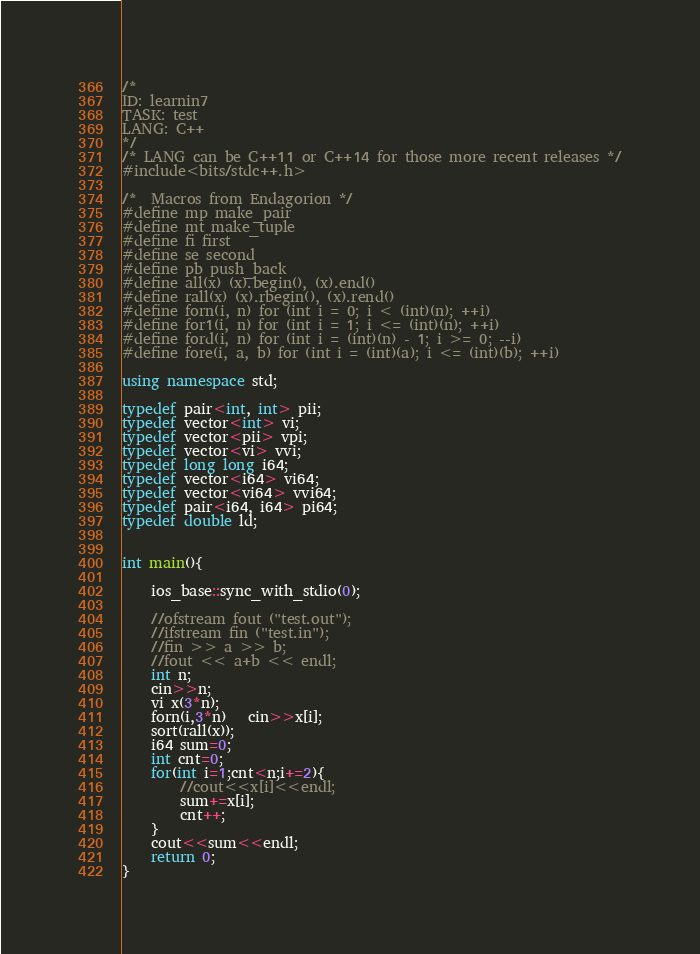Convert code to text. <code><loc_0><loc_0><loc_500><loc_500><_C++_>/*
ID: learnin7
TASK: test
LANG: C++                 
*/
/* LANG can be C++11 or C++14 for those more recent releases */
#include<bits/stdc++.h>

/*  Macros from Endagorion */
#define mp make_pair
#define mt make_tuple
#define fi first
#define se second
#define pb push_back
#define all(x) (x).begin(), (x).end()
#define rall(x) (x).rbegin(), (x).rend()
#define forn(i, n) for (int i = 0; i < (int)(n); ++i)
#define for1(i, n) for (int i = 1; i <= (int)(n); ++i)
#define ford(i, n) for (int i = (int)(n) - 1; i >= 0; --i)
#define fore(i, a, b) for (int i = (int)(a); i <= (int)(b); ++i)

using namespace std;

typedef pair<int, int> pii;
typedef vector<int> vi;
typedef vector<pii> vpi;
typedef vector<vi> vvi;
typedef long long i64;
typedef vector<i64> vi64;
typedef vector<vi64> vvi64;
typedef pair<i64, i64> pi64;
typedef double ld;


int main(){
        
    ios_base::sync_with_stdio(0);
    
    //ofstream fout ("test.out");
    //ifstream fin ("test.in");
    //fin >> a >> b;
    //fout << a+b << endl;
    int n;
    cin>>n;
    vi x(3*n);
    forn(i,3*n)   cin>>x[i];
    sort(rall(x));
    i64 sum=0;
    int cnt=0;
    for(int i=1;cnt<n;i+=2){
        //cout<<x[i]<<endl;
        sum+=x[i];
        cnt++;
    }
    cout<<sum<<endl;
    return 0;
}

</code> 